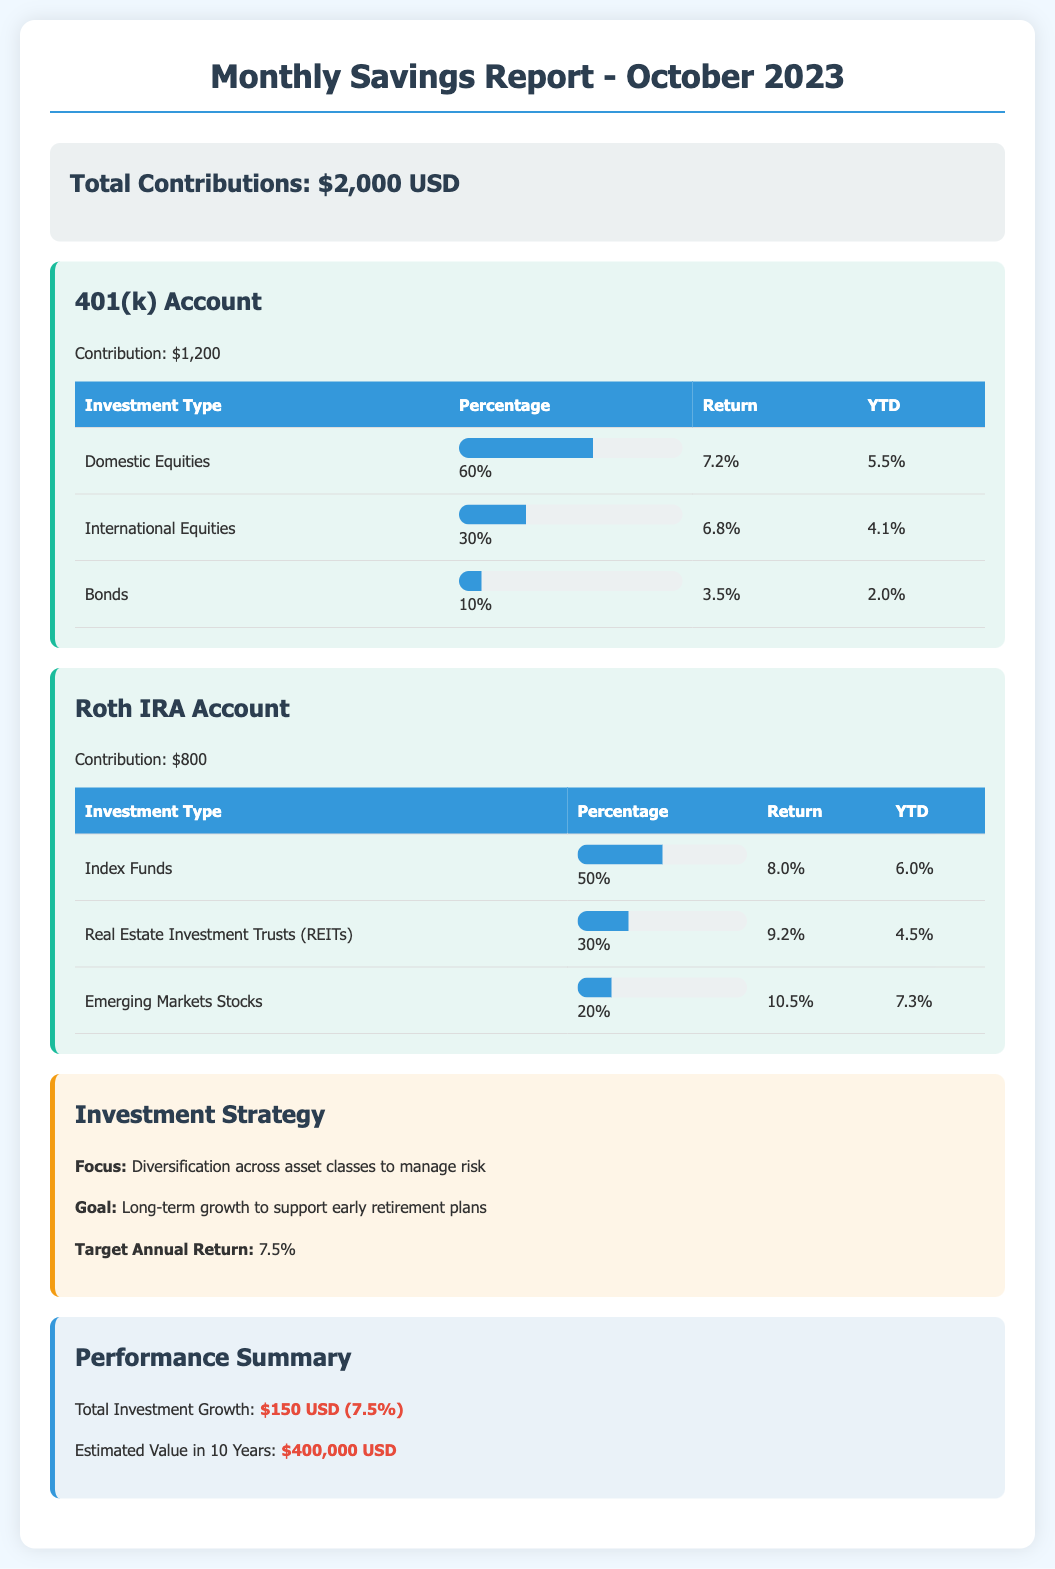What is the total contribution for October 2023? The total contribution is stated directly in the document as $2,000 USD.
Answer: $2,000 USD How much was contributed to the 401(k) account? The contribution amount for the 401(k) account is provided in the document, which is $1,200.
Answer: $1,200 What is the percentage of Domestic Equities in the 401(k) account? The document lists the percentage allocation for Domestic Equities in the 401(k) account, which is 60%.
Answer: 60% What is the return on Index Funds in the Roth IRA Account? The return for Index Funds in the Roth IRA is mentioned as 8.0%.
Answer: 8.0% What investment strategy is used in this report? The investment strategy focuses on diversification across asset classes to manage risk.
Answer: Diversification across asset classes What is the estimated value of investments in 10 years? The document specifies that the estimated value in 10 years is $400,000 USD.
Answer: $400,000 USD What is the total investment growth for October 2023? The performance summary indicates the total investment growth as $150 USD (7.5%).
Answer: $150 USD (7.5%) What is the goal of the investment strategy? The goal listed for the investment strategy is long-term growth to support early retirement plans.
Answer: Long-term growth to support early retirement plans How much was contributed to the Roth IRA account? The contribution amount for the Roth IRA account is explicitly stated in the report as $800.
Answer: $800 